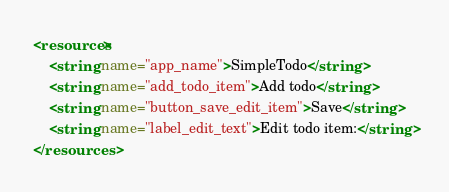<code> <loc_0><loc_0><loc_500><loc_500><_XML_><resources>
    <string name="app_name">SimpleTodo</string>
    <string name="add_todo_item">Add todo</string>
    <string name="button_save_edit_item">Save</string>
    <string name="label_edit_text">Edit todo item:</string>
</resources>
</code> 